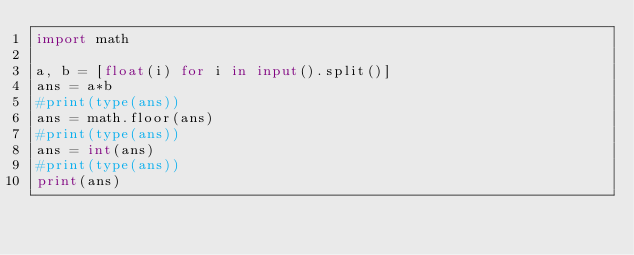Convert code to text. <code><loc_0><loc_0><loc_500><loc_500><_Python_>import math

a, b = [float(i) for i in input().split()]
ans = a*b
#print(type(ans))
ans = math.floor(ans)
#print(type(ans))
ans = int(ans)
#print(type(ans))
print(ans)
</code> 